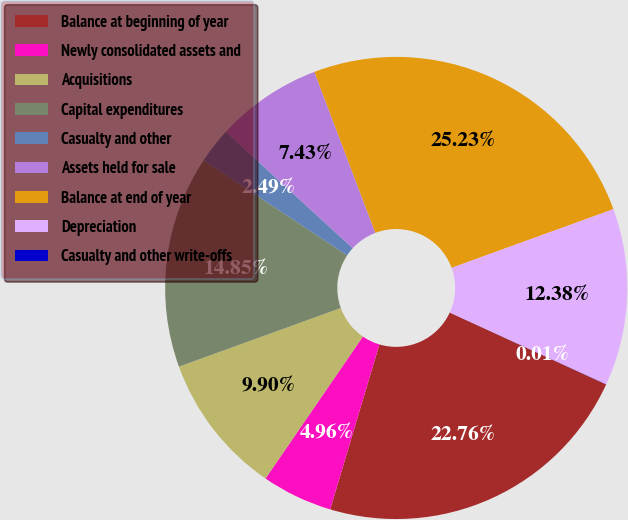Convert chart. <chart><loc_0><loc_0><loc_500><loc_500><pie_chart><fcel>Balance at beginning of year<fcel>Newly consolidated assets and<fcel>Acquisitions<fcel>Capital expenditures<fcel>Casualty and other<fcel>Assets held for sale<fcel>Balance at end of year<fcel>Depreciation<fcel>Casualty and other write-offs<nl><fcel>22.76%<fcel>4.96%<fcel>9.9%<fcel>14.85%<fcel>2.49%<fcel>7.43%<fcel>25.23%<fcel>12.38%<fcel>0.01%<nl></chart> 